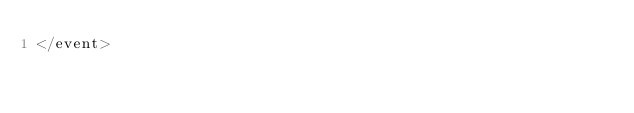Convert code to text. <code><loc_0><loc_0><loc_500><loc_500><_XML_></event>
</code> 